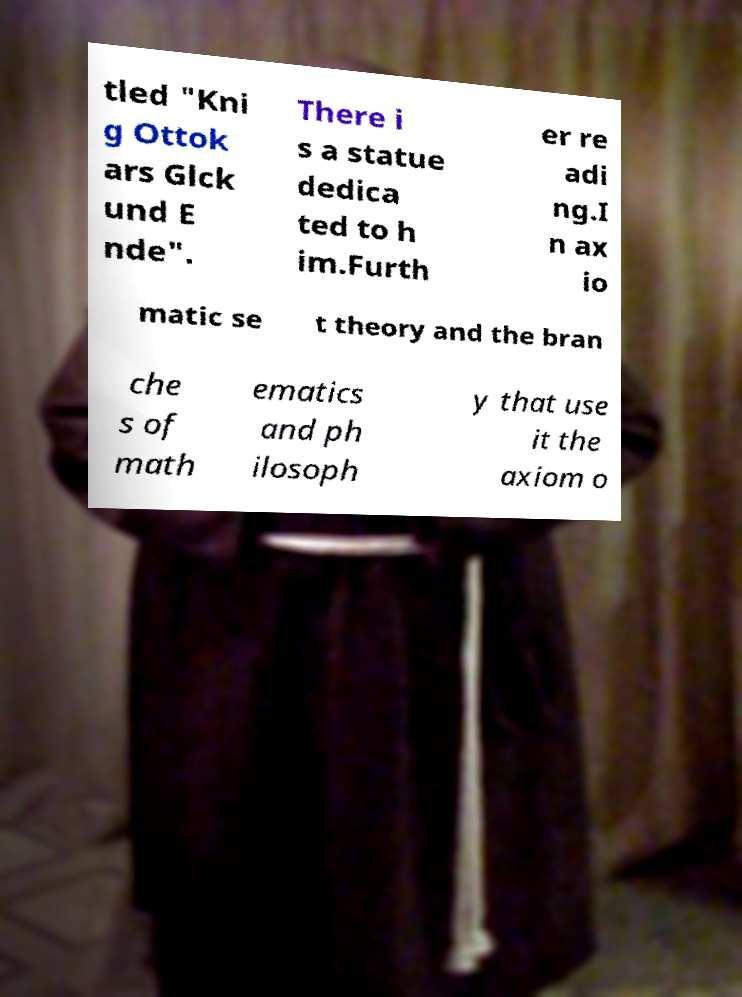Could you extract and type out the text from this image? tled "Kni g Ottok ars Glck und E nde". There i s a statue dedica ted to h im.Furth er re adi ng.I n ax io matic se t theory and the bran che s of math ematics and ph ilosoph y that use it the axiom o 